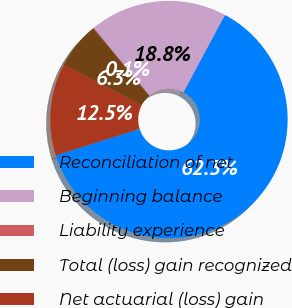Convert chart to OTSL. <chart><loc_0><loc_0><loc_500><loc_500><pie_chart><fcel>Reconciliation of net<fcel>Beginning balance<fcel>Liability experience<fcel>Total (loss) gain recognized<fcel>Net actuarial (loss) gain<nl><fcel>62.3%<fcel>18.76%<fcel>0.09%<fcel>6.31%<fcel>12.53%<nl></chart> 